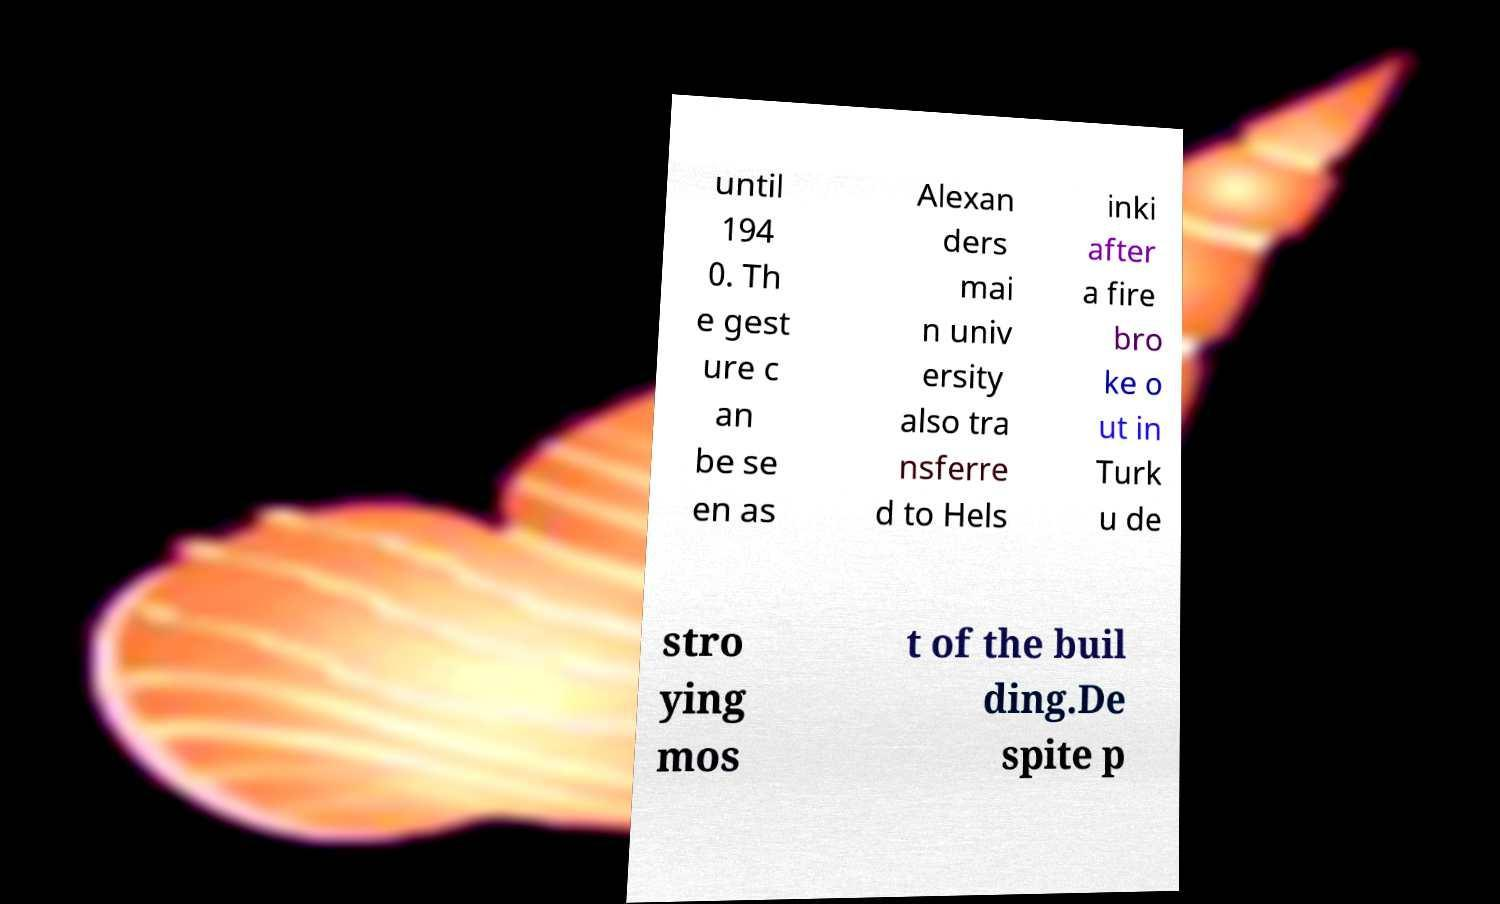Please identify and transcribe the text found in this image. until 194 0. Th e gest ure c an be se en as Alexan ders mai n univ ersity also tra nsferre d to Hels inki after a fire bro ke o ut in Turk u de stro ying mos t of the buil ding.De spite p 